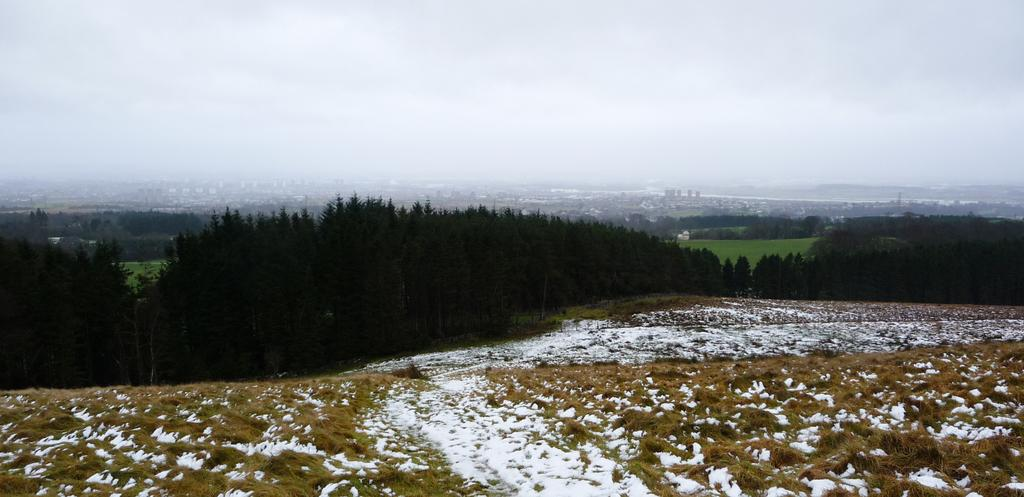What types of natural elements are present at the bottom of the image? There is snow and grass at the bottom of the image. What can be seen in the background of the image? There are trees, buildings, and grass in the background of the image. What type of structures are visible in the background? There are towers in the background of the image. What is visible at the top of the image? The sky is visible at the top of the image. What is the weather like in the image? The sky is cloudy in the image. What type of leather is being used to make the day in the image? There is no leather or day mentioned in the image; it features snow, grass, trees, buildings, towers, and a cloudy sky. 